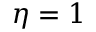<formula> <loc_0><loc_0><loc_500><loc_500>\eta = 1</formula> 